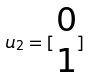<formula> <loc_0><loc_0><loc_500><loc_500>u _ { 2 } = [ \begin{matrix} 0 \\ 1 \end{matrix} ]</formula> 